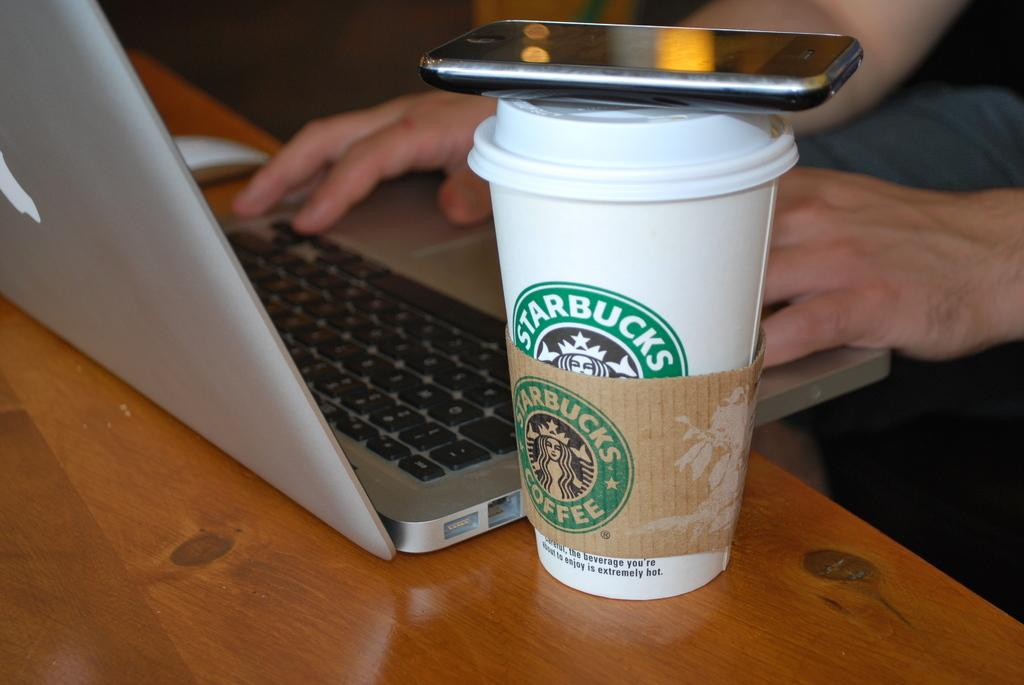<image>
Describe the image concisely. A Starbucks coffee cup with a cell phone sitting on the lid that is sitting next to a lap top on a table. 